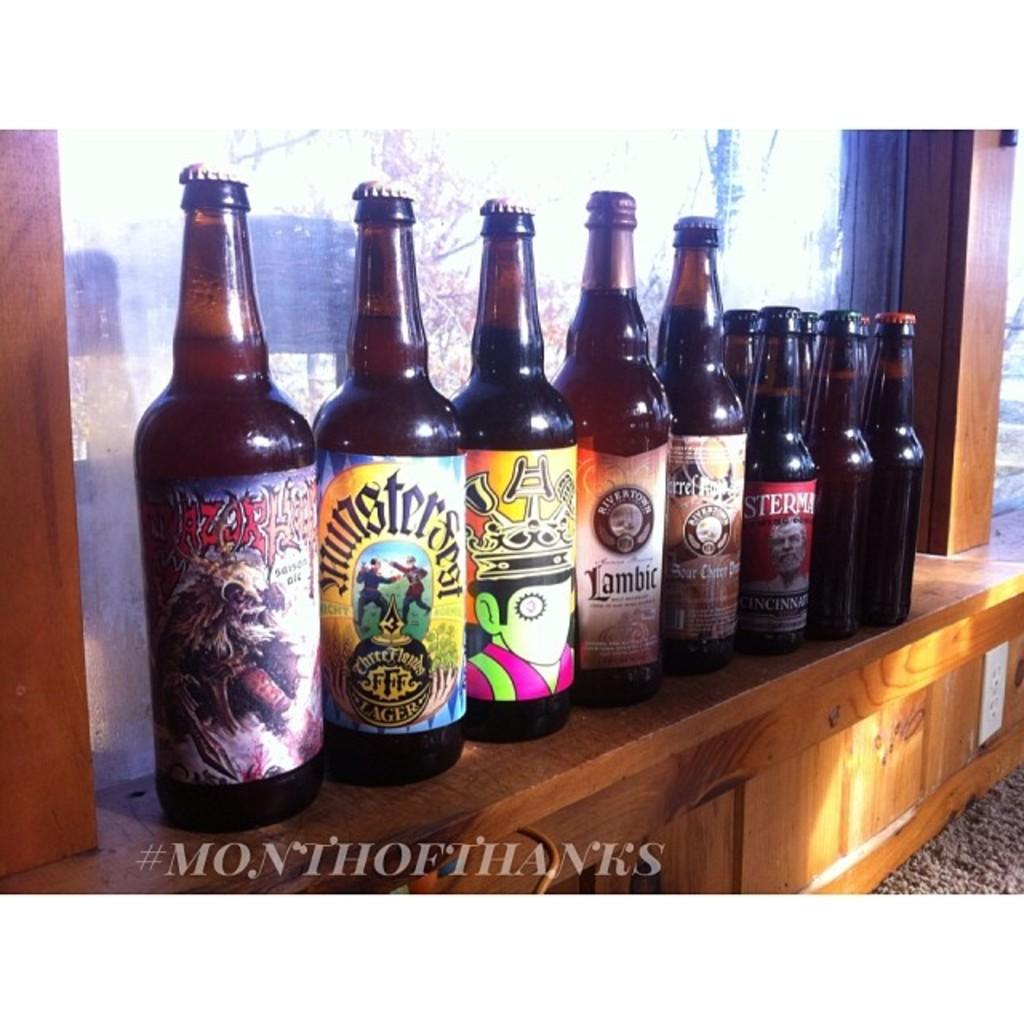What brand does the forth bottle from the left say?
Provide a short and direct response. Lambic. 